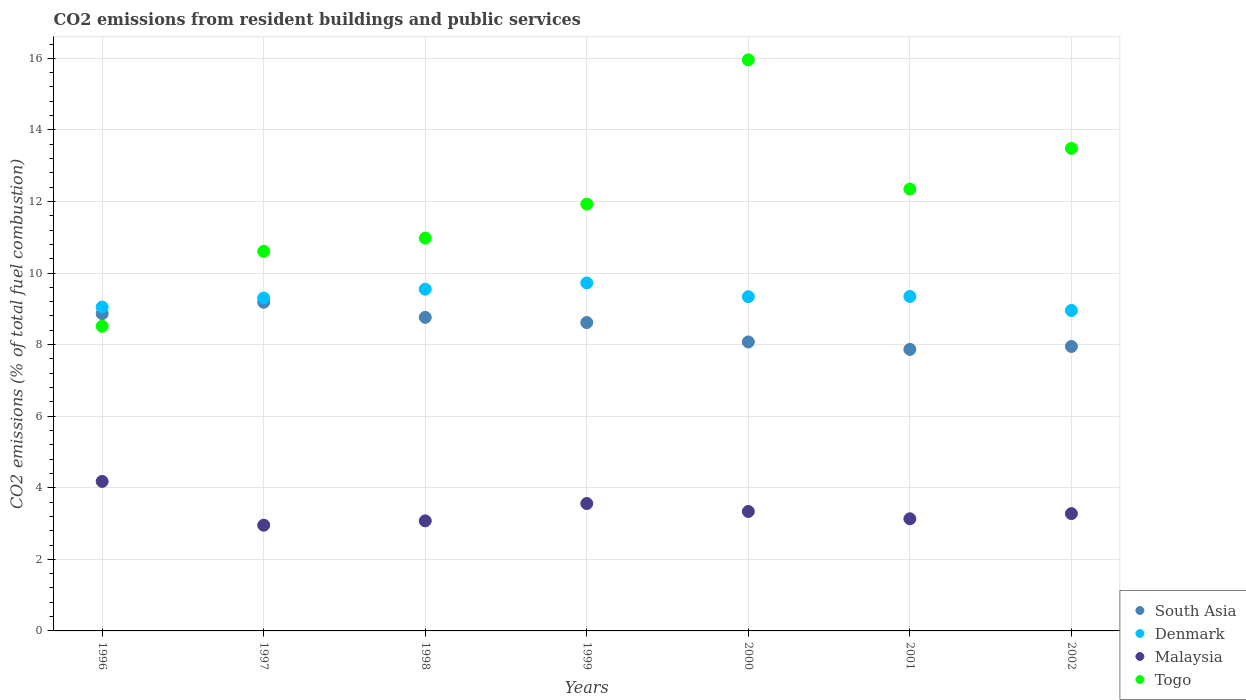How many different coloured dotlines are there?
Make the answer very short. 4. What is the total CO2 emitted in Togo in 1998?
Keep it short and to the point. 10.98. Across all years, what is the maximum total CO2 emitted in Malaysia?
Keep it short and to the point. 4.18. Across all years, what is the minimum total CO2 emitted in Malaysia?
Make the answer very short. 2.95. What is the total total CO2 emitted in South Asia in the graph?
Provide a short and direct response. 59.32. What is the difference between the total CO2 emitted in Malaysia in 1998 and that in 2000?
Your answer should be compact. -0.26. What is the difference between the total CO2 emitted in South Asia in 1999 and the total CO2 emitted in Denmark in 2001?
Provide a short and direct response. -0.73. What is the average total CO2 emitted in Malaysia per year?
Your response must be concise. 3.36. In the year 1998, what is the difference between the total CO2 emitted in Denmark and total CO2 emitted in South Asia?
Your answer should be very brief. 0.79. What is the ratio of the total CO2 emitted in Denmark in 1998 to that in 2001?
Your answer should be compact. 1.02. What is the difference between the highest and the second highest total CO2 emitted in Malaysia?
Your answer should be compact. 0.62. What is the difference between the highest and the lowest total CO2 emitted in Togo?
Your answer should be very brief. 7.45. In how many years, is the total CO2 emitted in Malaysia greater than the average total CO2 emitted in Malaysia taken over all years?
Offer a very short reply. 2. Is the sum of the total CO2 emitted in Togo in 2000 and 2001 greater than the maximum total CO2 emitted in Malaysia across all years?
Give a very brief answer. Yes. Is it the case that in every year, the sum of the total CO2 emitted in Denmark and total CO2 emitted in Togo  is greater than the total CO2 emitted in South Asia?
Ensure brevity in your answer.  Yes. Is the total CO2 emitted in Denmark strictly greater than the total CO2 emitted in Malaysia over the years?
Give a very brief answer. Yes. Is the total CO2 emitted in Denmark strictly less than the total CO2 emitted in Togo over the years?
Provide a short and direct response. No. Are the values on the major ticks of Y-axis written in scientific E-notation?
Offer a terse response. No. Does the graph contain grids?
Provide a short and direct response. Yes. How are the legend labels stacked?
Your response must be concise. Vertical. What is the title of the graph?
Your answer should be compact. CO2 emissions from resident buildings and public services. Does "Fragile and conflict affected situations" appear as one of the legend labels in the graph?
Ensure brevity in your answer.  No. What is the label or title of the Y-axis?
Your response must be concise. CO2 emissions (% of total fuel combustion). What is the CO2 emissions (% of total fuel combustion) in South Asia in 1996?
Offer a very short reply. 8.86. What is the CO2 emissions (% of total fuel combustion) in Denmark in 1996?
Your response must be concise. 9.05. What is the CO2 emissions (% of total fuel combustion) in Malaysia in 1996?
Provide a succinct answer. 4.18. What is the CO2 emissions (% of total fuel combustion) of Togo in 1996?
Make the answer very short. 8.51. What is the CO2 emissions (% of total fuel combustion) of South Asia in 1997?
Offer a very short reply. 9.18. What is the CO2 emissions (% of total fuel combustion) of Denmark in 1997?
Your answer should be compact. 9.3. What is the CO2 emissions (% of total fuel combustion) in Malaysia in 1997?
Your answer should be very brief. 2.95. What is the CO2 emissions (% of total fuel combustion) in Togo in 1997?
Ensure brevity in your answer.  10.61. What is the CO2 emissions (% of total fuel combustion) of South Asia in 1998?
Keep it short and to the point. 8.76. What is the CO2 emissions (% of total fuel combustion) of Denmark in 1998?
Offer a terse response. 9.55. What is the CO2 emissions (% of total fuel combustion) in Malaysia in 1998?
Offer a very short reply. 3.08. What is the CO2 emissions (% of total fuel combustion) in Togo in 1998?
Your answer should be very brief. 10.98. What is the CO2 emissions (% of total fuel combustion) in South Asia in 1999?
Provide a succinct answer. 8.62. What is the CO2 emissions (% of total fuel combustion) in Denmark in 1999?
Your answer should be very brief. 9.72. What is the CO2 emissions (% of total fuel combustion) of Malaysia in 1999?
Your answer should be compact. 3.56. What is the CO2 emissions (% of total fuel combustion) of Togo in 1999?
Provide a short and direct response. 11.93. What is the CO2 emissions (% of total fuel combustion) in South Asia in 2000?
Ensure brevity in your answer.  8.08. What is the CO2 emissions (% of total fuel combustion) of Denmark in 2000?
Your response must be concise. 9.34. What is the CO2 emissions (% of total fuel combustion) in Malaysia in 2000?
Provide a succinct answer. 3.34. What is the CO2 emissions (% of total fuel combustion) of Togo in 2000?
Your answer should be very brief. 15.96. What is the CO2 emissions (% of total fuel combustion) of South Asia in 2001?
Your response must be concise. 7.87. What is the CO2 emissions (% of total fuel combustion) of Denmark in 2001?
Provide a succinct answer. 9.34. What is the CO2 emissions (% of total fuel combustion) of Malaysia in 2001?
Your answer should be very brief. 3.13. What is the CO2 emissions (% of total fuel combustion) in Togo in 2001?
Ensure brevity in your answer.  12.35. What is the CO2 emissions (% of total fuel combustion) of South Asia in 2002?
Your response must be concise. 7.95. What is the CO2 emissions (% of total fuel combustion) in Denmark in 2002?
Offer a very short reply. 8.95. What is the CO2 emissions (% of total fuel combustion) in Malaysia in 2002?
Offer a terse response. 3.28. What is the CO2 emissions (% of total fuel combustion) of Togo in 2002?
Your answer should be compact. 13.48. Across all years, what is the maximum CO2 emissions (% of total fuel combustion) of South Asia?
Give a very brief answer. 9.18. Across all years, what is the maximum CO2 emissions (% of total fuel combustion) of Denmark?
Provide a succinct answer. 9.72. Across all years, what is the maximum CO2 emissions (% of total fuel combustion) in Malaysia?
Make the answer very short. 4.18. Across all years, what is the maximum CO2 emissions (% of total fuel combustion) of Togo?
Your answer should be very brief. 15.96. Across all years, what is the minimum CO2 emissions (% of total fuel combustion) in South Asia?
Provide a succinct answer. 7.87. Across all years, what is the minimum CO2 emissions (% of total fuel combustion) of Denmark?
Offer a terse response. 8.95. Across all years, what is the minimum CO2 emissions (% of total fuel combustion) of Malaysia?
Offer a very short reply. 2.95. Across all years, what is the minimum CO2 emissions (% of total fuel combustion) in Togo?
Your answer should be very brief. 8.51. What is the total CO2 emissions (% of total fuel combustion) in South Asia in the graph?
Your response must be concise. 59.32. What is the total CO2 emissions (% of total fuel combustion) in Denmark in the graph?
Provide a short and direct response. 65.26. What is the total CO2 emissions (% of total fuel combustion) of Malaysia in the graph?
Give a very brief answer. 23.52. What is the total CO2 emissions (% of total fuel combustion) of Togo in the graph?
Offer a terse response. 83.81. What is the difference between the CO2 emissions (% of total fuel combustion) of South Asia in 1996 and that in 1997?
Your answer should be very brief. -0.32. What is the difference between the CO2 emissions (% of total fuel combustion) in Denmark in 1996 and that in 1997?
Keep it short and to the point. -0.25. What is the difference between the CO2 emissions (% of total fuel combustion) in Malaysia in 1996 and that in 1997?
Offer a terse response. 1.22. What is the difference between the CO2 emissions (% of total fuel combustion) in Togo in 1996 and that in 1997?
Keep it short and to the point. -2.1. What is the difference between the CO2 emissions (% of total fuel combustion) of South Asia in 1996 and that in 1998?
Offer a terse response. 0.1. What is the difference between the CO2 emissions (% of total fuel combustion) in Denmark in 1996 and that in 1998?
Make the answer very short. -0.5. What is the difference between the CO2 emissions (% of total fuel combustion) in Malaysia in 1996 and that in 1998?
Make the answer very short. 1.1. What is the difference between the CO2 emissions (% of total fuel combustion) in Togo in 1996 and that in 1998?
Your response must be concise. -2.46. What is the difference between the CO2 emissions (% of total fuel combustion) of South Asia in 1996 and that in 1999?
Provide a succinct answer. 0.25. What is the difference between the CO2 emissions (% of total fuel combustion) in Denmark in 1996 and that in 1999?
Provide a short and direct response. -0.68. What is the difference between the CO2 emissions (% of total fuel combustion) of Malaysia in 1996 and that in 1999?
Keep it short and to the point. 0.62. What is the difference between the CO2 emissions (% of total fuel combustion) in Togo in 1996 and that in 1999?
Keep it short and to the point. -3.42. What is the difference between the CO2 emissions (% of total fuel combustion) in South Asia in 1996 and that in 2000?
Offer a terse response. 0.79. What is the difference between the CO2 emissions (% of total fuel combustion) in Denmark in 1996 and that in 2000?
Ensure brevity in your answer.  -0.29. What is the difference between the CO2 emissions (% of total fuel combustion) in Malaysia in 1996 and that in 2000?
Give a very brief answer. 0.84. What is the difference between the CO2 emissions (% of total fuel combustion) of Togo in 1996 and that in 2000?
Offer a terse response. -7.45. What is the difference between the CO2 emissions (% of total fuel combustion) in South Asia in 1996 and that in 2001?
Give a very brief answer. 1. What is the difference between the CO2 emissions (% of total fuel combustion) in Denmark in 1996 and that in 2001?
Offer a terse response. -0.3. What is the difference between the CO2 emissions (% of total fuel combustion) in Malaysia in 1996 and that in 2001?
Provide a short and direct response. 1.04. What is the difference between the CO2 emissions (% of total fuel combustion) of Togo in 1996 and that in 2001?
Offer a terse response. -3.83. What is the difference between the CO2 emissions (% of total fuel combustion) of South Asia in 1996 and that in 2002?
Provide a succinct answer. 0.92. What is the difference between the CO2 emissions (% of total fuel combustion) of Denmark in 1996 and that in 2002?
Keep it short and to the point. 0.09. What is the difference between the CO2 emissions (% of total fuel combustion) in Malaysia in 1996 and that in 2002?
Keep it short and to the point. 0.9. What is the difference between the CO2 emissions (% of total fuel combustion) in Togo in 1996 and that in 2002?
Offer a very short reply. -4.97. What is the difference between the CO2 emissions (% of total fuel combustion) of South Asia in 1997 and that in 1998?
Your answer should be very brief. 0.42. What is the difference between the CO2 emissions (% of total fuel combustion) in Denmark in 1997 and that in 1998?
Ensure brevity in your answer.  -0.25. What is the difference between the CO2 emissions (% of total fuel combustion) in Malaysia in 1997 and that in 1998?
Provide a short and direct response. -0.12. What is the difference between the CO2 emissions (% of total fuel combustion) of Togo in 1997 and that in 1998?
Ensure brevity in your answer.  -0.37. What is the difference between the CO2 emissions (% of total fuel combustion) of South Asia in 1997 and that in 1999?
Your response must be concise. 0.57. What is the difference between the CO2 emissions (% of total fuel combustion) in Denmark in 1997 and that in 1999?
Keep it short and to the point. -0.42. What is the difference between the CO2 emissions (% of total fuel combustion) of Malaysia in 1997 and that in 1999?
Keep it short and to the point. -0.61. What is the difference between the CO2 emissions (% of total fuel combustion) in Togo in 1997 and that in 1999?
Offer a very short reply. -1.32. What is the difference between the CO2 emissions (% of total fuel combustion) in South Asia in 1997 and that in 2000?
Ensure brevity in your answer.  1.11. What is the difference between the CO2 emissions (% of total fuel combustion) of Denmark in 1997 and that in 2000?
Your answer should be very brief. -0.04. What is the difference between the CO2 emissions (% of total fuel combustion) of Malaysia in 1997 and that in 2000?
Ensure brevity in your answer.  -0.38. What is the difference between the CO2 emissions (% of total fuel combustion) of Togo in 1997 and that in 2000?
Make the answer very short. -5.35. What is the difference between the CO2 emissions (% of total fuel combustion) in South Asia in 1997 and that in 2001?
Provide a short and direct response. 1.32. What is the difference between the CO2 emissions (% of total fuel combustion) in Denmark in 1997 and that in 2001?
Your response must be concise. -0.04. What is the difference between the CO2 emissions (% of total fuel combustion) in Malaysia in 1997 and that in 2001?
Offer a very short reply. -0.18. What is the difference between the CO2 emissions (% of total fuel combustion) in Togo in 1997 and that in 2001?
Your answer should be compact. -1.74. What is the difference between the CO2 emissions (% of total fuel combustion) of South Asia in 1997 and that in 2002?
Provide a short and direct response. 1.24. What is the difference between the CO2 emissions (% of total fuel combustion) in Denmark in 1997 and that in 2002?
Make the answer very short. 0.35. What is the difference between the CO2 emissions (% of total fuel combustion) of Malaysia in 1997 and that in 2002?
Provide a short and direct response. -0.32. What is the difference between the CO2 emissions (% of total fuel combustion) in Togo in 1997 and that in 2002?
Give a very brief answer. -2.88. What is the difference between the CO2 emissions (% of total fuel combustion) in South Asia in 1998 and that in 1999?
Give a very brief answer. 0.15. What is the difference between the CO2 emissions (% of total fuel combustion) in Denmark in 1998 and that in 1999?
Your response must be concise. -0.18. What is the difference between the CO2 emissions (% of total fuel combustion) in Malaysia in 1998 and that in 1999?
Ensure brevity in your answer.  -0.48. What is the difference between the CO2 emissions (% of total fuel combustion) in Togo in 1998 and that in 1999?
Offer a terse response. -0.95. What is the difference between the CO2 emissions (% of total fuel combustion) of South Asia in 1998 and that in 2000?
Ensure brevity in your answer.  0.69. What is the difference between the CO2 emissions (% of total fuel combustion) of Denmark in 1998 and that in 2000?
Your response must be concise. 0.21. What is the difference between the CO2 emissions (% of total fuel combustion) in Malaysia in 1998 and that in 2000?
Your answer should be very brief. -0.26. What is the difference between the CO2 emissions (% of total fuel combustion) in Togo in 1998 and that in 2000?
Ensure brevity in your answer.  -4.98. What is the difference between the CO2 emissions (% of total fuel combustion) of South Asia in 1998 and that in 2001?
Offer a very short reply. 0.9. What is the difference between the CO2 emissions (% of total fuel combustion) of Denmark in 1998 and that in 2001?
Keep it short and to the point. 0.2. What is the difference between the CO2 emissions (% of total fuel combustion) of Malaysia in 1998 and that in 2001?
Your response must be concise. -0.06. What is the difference between the CO2 emissions (% of total fuel combustion) in Togo in 1998 and that in 2001?
Provide a short and direct response. -1.37. What is the difference between the CO2 emissions (% of total fuel combustion) in South Asia in 1998 and that in 2002?
Make the answer very short. 0.81. What is the difference between the CO2 emissions (% of total fuel combustion) of Denmark in 1998 and that in 2002?
Provide a succinct answer. 0.59. What is the difference between the CO2 emissions (% of total fuel combustion) of Malaysia in 1998 and that in 2002?
Provide a short and direct response. -0.2. What is the difference between the CO2 emissions (% of total fuel combustion) in Togo in 1998 and that in 2002?
Ensure brevity in your answer.  -2.51. What is the difference between the CO2 emissions (% of total fuel combustion) of South Asia in 1999 and that in 2000?
Your response must be concise. 0.54. What is the difference between the CO2 emissions (% of total fuel combustion) in Denmark in 1999 and that in 2000?
Ensure brevity in your answer.  0.39. What is the difference between the CO2 emissions (% of total fuel combustion) in Malaysia in 1999 and that in 2000?
Your response must be concise. 0.22. What is the difference between the CO2 emissions (% of total fuel combustion) in Togo in 1999 and that in 2000?
Offer a very short reply. -4.03. What is the difference between the CO2 emissions (% of total fuel combustion) in South Asia in 1999 and that in 2001?
Offer a very short reply. 0.75. What is the difference between the CO2 emissions (% of total fuel combustion) in Denmark in 1999 and that in 2001?
Your response must be concise. 0.38. What is the difference between the CO2 emissions (% of total fuel combustion) in Malaysia in 1999 and that in 2001?
Your answer should be compact. 0.43. What is the difference between the CO2 emissions (% of total fuel combustion) in Togo in 1999 and that in 2001?
Make the answer very short. -0.42. What is the difference between the CO2 emissions (% of total fuel combustion) of South Asia in 1999 and that in 2002?
Your response must be concise. 0.67. What is the difference between the CO2 emissions (% of total fuel combustion) in Denmark in 1999 and that in 2002?
Ensure brevity in your answer.  0.77. What is the difference between the CO2 emissions (% of total fuel combustion) in Malaysia in 1999 and that in 2002?
Offer a very short reply. 0.28. What is the difference between the CO2 emissions (% of total fuel combustion) of Togo in 1999 and that in 2002?
Give a very brief answer. -1.56. What is the difference between the CO2 emissions (% of total fuel combustion) in South Asia in 2000 and that in 2001?
Give a very brief answer. 0.21. What is the difference between the CO2 emissions (% of total fuel combustion) of Denmark in 2000 and that in 2001?
Give a very brief answer. -0.01. What is the difference between the CO2 emissions (% of total fuel combustion) of Malaysia in 2000 and that in 2001?
Make the answer very short. 0.2. What is the difference between the CO2 emissions (% of total fuel combustion) of Togo in 2000 and that in 2001?
Ensure brevity in your answer.  3.61. What is the difference between the CO2 emissions (% of total fuel combustion) in South Asia in 2000 and that in 2002?
Provide a succinct answer. 0.13. What is the difference between the CO2 emissions (% of total fuel combustion) of Denmark in 2000 and that in 2002?
Your answer should be compact. 0.38. What is the difference between the CO2 emissions (% of total fuel combustion) of Malaysia in 2000 and that in 2002?
Make the answer very short. 0.06. What is the difference between the CO2 emissions (% of total fuel combustion) in Togo in 2000 and that in 2002?
Your answer should be very brief. 2.47. What is the difference between the CO2 emissions (% of total fuel combustion) of South Asia in 2001 and that in 2002?
Offer a terse response. -0.08. What is the difference between the CO2 emissions (% of total fuel combustion) of Denmark in 2001 and that in 2002?
Provide a short and direct response. 0.39. What is the difference between the CO2 emissions (% of total fuel combustion) of Malaysia in 2001 and that in 2002?
Provide a succinct answer. -0.14. What is the difference between the CO2 emissions (% of total fuel combustion) in Togo in 2001 and that in 2002?
Provide a succinct answer. -1.14. What is the difference between the CO2 emissions (% of total fuel combustion) of South Asia in 1996 and the CO2 emissions (% of total fuel combustion) of Denmark in 1997?
Keep it short and to the point. -0.44. What is the difference between the CO2 emissions (% of total fuel combustion) in South Asia in 1996 and the CO2 emissions (% of total fuel combustion) in Malaysia in 1997?
Give a very brief answer. 5.91. What is the difference between the CO2 emissions (% of total fuel combustion) in South Asia in 1996 and the CO2 emissions (% of total fuel combustion) in Togo in 1997?
Provide a succinct answer. -1.74. What is the difference between the CO2 emissions (% of total fuel combustion) of Denmark in 1996 and the CO2 emissions (% of total fuel combustion) of Malaysia in 1997?
Offer a terse response. 6.09. What is the difference between the CO2 emissions (% of total fuel combustion) of Denmark in 1996 and the CO2 emissions (% of total fuel combustion) of Togo in 1997?
Give a very brief answer. -1.56. What is the difference between the CO2 emissions (% of total fuel combustion) of Malaysia in 1996 and the CO2 emissions (% of total fuel combustion) of Togo in 1997?
Your answer should be very brief. -6.43. What is the difference between the CO2 emissions (% of total fuel combustion) in South Asia in 1996 and the CO2 emissions (% of total fuel combustion) in Denmark in 1998?
Your response must be concise. -0.68. What is the difference between the CO2 emissions (% of total fuel combustion) of South Asia in 1996 and the CO2 emissions (% of total fuel combustion) of Malaysia in 1998?
Your answer should be compact. 5.79. What is the difference between the CO2 emissions (% of total fuel combustion) in South Asia in 1996 and the CO2 emissions (% of total fuel combustion) in Togo in 1998?
Provide a short and direct response. -2.11. What is the difference between the CO2 emissions (% of total fuel combustion) of Denmark in 1996 and the CO2 emissions (% of total fuel combustion) of Malaysia in 1998?
Ensure brevity in your answer.  5.97. What is the difference between the CO2 emissions (% of total fuel combustion) of Denmark in 1996 and the CO2 emissions (% of total fuel combustion) of Togo in 1998?
Ensure brevity in your answer.  -1.93. What is the difference between the CO2 emissions (% of total fuel combustion) of Malaysia in 1996 and the CO2 emissions (% of total fuel combustion) of Togo in 1998?
Ensure brevity in your answer.  -6.8. What is the difference between the CO2 emissions (% of total fuel combustion) in South Asia in 1996 and the CO2 emissions (% of total fuel combustion) in Denmark in 1999?
Provide a short and direct response. -0.86. What is the difference between the CO2 emissions (% of total fuel combustion) of South Asia in 1996 and the CO2 emissions (% of total fuel combustion) of Malaysia in 1999?
Keep it short and to the point. 5.3. What is the difference between the CO2 emissions (% of total fuel combustion) of South Asia in 1996 and the CO2 emissions (% of total fuel combustion) of Togo in 1999?
Your answer should be compact. -3.06. What is the difference between the CO2 emissions (% of total fuel combustion) in Denmark in 1996 and the CO2 emissions (% of total fuel combustion) in Malaysia in 1999?
Your response must be concise. 5.49. What is the difference between the CO2 emissions (% of total fuel combustion) in Denmark in 1996 and the CO2 emissions (% of total fuel combustion) in Togo in 1999?
Your answer should be compact. -2.88. What is the difference between the CO2 emissions (% of total fuel combustion) of Malaysia in 1996 and the CO2 emissions (% of total fuel combustion) of Togo in 1999?
Offer a terse response. -7.75. What is the difference between the CO2 emissions (% of total fuel combustion) in South Asia in 1996 and the CO2 emissions (% of total fuel combustion) in Denmark in 2000?
Offer a very short reply. -0.47. What is the difference between the CO2 emissions (% of total fuel combustion) of South Asia in 1996 and the CO2 emissions (% of total fuel combustion) of Malaysia in 2000?
Offer a terse response. 5.53. What is the difference between the CO2 emissions (% of total fuel combustion) of South Asia in 1996 and the CO2 emissions (% of total fuel combustion) of Togo in 2000?
Provide a succinct answer. -7.09. What is the difference between the CO2 emissions (% of total fuel combustion) in Denmark in 1996 and the CO2 emissions (% of total fuel combustion) in Malaysia in 2000?
Offer a very short reply. 5.71. What is the difference between the CO2 emissions (% of total fuel combustion) in Denmark in 1996 and the CO2 emissions (% of total fuel combustion) in Togo in 2000?
Ensure brevity in your answer.  -6.91. What is the difference between the CO2 emissions (% of total fuel combustion) of Malaysia in 1996 and the CO2 emissions (% of total fuel combustion) of Togo in 2000?
Give a very brief answer. -11.78. What is the difference between the CO2 emissions (% of total fuel combustion) in South Asia in 1996 and the CO2 emissions (% of total fuel combustion) in Denmark in 2001?
Offer a terse response. -0.48. What is the difference between the CO2 emissions (% of total fuel combustion) of South Asia in 1996 and the CO2 emissions (% of total fuel combustion) of Malaysia in 2001?
Provide a succinct answer. 5.73. What is the difference between the CO2 emissions (% of total fuel combustion) in South Asia in 1996 and the CO2 emissions (% of total fuel combustion) in Togo in 2001?
Ensure brevity in your answer.  -3.48. What is the difference between the CO2 emissions (% of total fuel combustion) of Denmark in 1996 and the CO2 emissions (% of total fuel combustion) of Malaysia in 2001?
Offer a very short reply. 5.92. What is the difference between the CO2 emissions (% of total fuel combustion) of Denmark in 1996 and the CO2 emissions (% of total fuel combustion) of Togo in 2001?
Give a very brief answer. -3.3. What is the difference between the CO2 emissions (% of total fuel combustion) of Malaysia in 1996 and the CO2 emissions (% of total fuel combustion) of Togo in 2001?
Make the answer very short. -8.17. What is the difference between the CO2 emissions (% of total fuel combustion) in South Asia in 1996 and the CO2 emissions (% of total fuel combustion) in Denmark in 2002?
Your answer should be compact. -0.09. What is the difference between the CO2 emissions (% of total fuel combustion) of South Asia in 1996 and the CO2 emissions (% of total fuel combustion) of Malaysia in 2002?
Your answer should be very brief. 5.59. What is the difference between the CO2 emissions (% of total fuel combustion) in South Asia in 1996 and the CO2 emissions (% of total fuel combustion) in Togo in 2002?
Your response must be concise. -4.62. What is the difference between the CO2 emissions (% of total fuel combustion) in Denmark in 1996 and the CO2 emissions (% of total fuel combustion) in Malaysia in 2002?
Offer a terse response. 5.77. What is the difference between the CO2 emissions (% of total fuel combustion) of Denmark in 1996 and the CO2 emissions (% of total fuel combustion) of Togo in 2002?
Make the answer very short. -4.43. What is the difference between the CO2 emissions (% of total fuel combustion) of Malaysia in 1996 and the CO2 emissions (% of total fuel combustion) of Togo in 2002?
Your response must be concise. -9.31. What is the difference between the CO2 emissions (% of total fuel combustion) in South Asia in 1997 and the CO2 emissions (% of total fuel combustion) in Denmark in 1998?
Offer a terse response. -0.36. What is the difference between the CO2 emissions (% of total fuel combustion) of South Asia in 1997 and the CO2 emissions (% of total fuel combustion) of Malaysia in 1998?
Keep it short and to the point. 6.11. What is the difference between the CO2 emissions (% of total fuel combustion) in South Asia in 1997 and the CO2 emissions (% of total fuel combustion) in Togo in 1998?
Your answer should be compact. -1.79. What is the difference between the CO2 emissions (% of total fuel combustion) of Denmark in 1997 and the CO2 emissions (% of total fuel combustion) of Malaysia in 1998?
Your response must be concise. 6.23. What is the difference between the CO2 emissions (% of total fuel combustion) in Denmark in 1997 and the CO2 emissions (% of total fuel combustion) in Togo in 1998?
Keep it short and to the point. -1.67. What is the difference between the CO2 emissions (% of total fuel combustion) in Malaysia in 1997 and the CO2 emissions (% of total fuel combustion) in Togo in 1998?
Your answer should be very brief. -8.02. What is the difference between the CO2 emissions (% of total fuel combustion) in South Asia in 1997 and the CO2 emissions (% of total fuel combustion) in Denmark in 1999?
Provide a short and direct response. -0.54. What is the difference between the CO2 emissions (% of total fuel combustion) of South Asia in 1997 and the CO2 emissions (% of total fuel combustion) of Malaysia in 1999?
Keep it short and to the point. 5.62. What is the difference between the CO2 emissions (% of total fuel combustion) of South Asia in 1997 and the CO2 emissions (% of total fuel combustion) of Togo in 1999?
Keep it short and to the point. -2.74. What is the difference between the CO2 emissions (% of total fuel combustion) in Denmark in 1997 and the CO2 emissions (% of total fuel combustion) in Malaysia in 1999?
Give a very brief answer. 5.74. What is the difference between the CO2 emissions (% of total fuel combustion) of Denmark in 1997 and the CO2 emissions (% of total fuel combustion) of Togo in 1999?
Your answer should be compact. -2.62. What is the difference between the CO2 emissions (% of total fuel combustion) of Malaysia in 1997 and the CO2 emissions (% of total fuel combustion) of Togo in 1999?
Offer a terse response. -8.97. What is the difference between the CO2 emissions (% of total fuel combustion) of South Asia in 1997 and the CO2 emissions (% of total fuel combustion) of Denmark in 2000?
Offer a terse response. -0.15. What is the difference between the CO2 emissions (% of total fuel combustion) in South Asia in 1997 and the CO2 emissions (% of total fuel combustion) in Malaysia in 2000?
Keep it short and to the point. 5.85. What is the difference between the CO2 emissions (% of total fuel combustion) of South Asia in 1997 and the CO2 emissions (% of total fuel combustion) of Togo in 2000?
Your response must be concise. -6.77. What is the difference between the CO2 emissions (% of total fuel combustion) of Denmark in 1997 and the CO2 emissions (% of total fuel combustion) of Malaysia in 2000?
Give a very brief answer. 5.97. What is the difference between the CO2 emissions (% of total fuel combustion) in Denmark in 1997 and the CO2 emissions (% of total fuel combustion) in Togo in 2000?
Your answer should be compact. -6.65. What is the difference between the CO2 emissions (% of total fuel combustion) of Malaysia in 1997 and the CO2 emissions (% of total fuel combustion) of Togo in 2000?
Provide a short and direct response. -13. What is the difference between the CO2 emissions (% of total fuel combustion) of South Asia in 1997 and the CO2 emissions (% of total fuel combustion) of Denmark in 2001?
Your answer should be compact. -0.16. What is the difference between the CO2 emissions (% of total fuel combustion) of South Asia in 1997 and the CO2 emissions (% of total fuel combustion) of Malaysia in 2001?
Give a very brief answer. 6.05. What is the difference between the CO2 emissions (% of total fuel combustion) in South Asia in 1997 and the CO2 emissions (% of total fuel combustion) in Togo in 2001?
Make the answer very short. -3.16. What is the difference between the CO2 emissions (% of total fuel combustion) of Denmark in 1997 and the CO2 emissions (% of total fuel combustion) of Malaysia in 2001?
Your response must be concise. 6.17. What is the difference between the CO2 emissions (% of total fuel combustion) in Denmark in 1997 and the CO2 emissions (% of total fuel combustion) in Togo in 2001?
Your response must be concise. -3.04. What is the difference between the CO2 emissions (% of total fuel combustion) in Malaysia in 1997 and the CO2 emissions (% of total fuel combustion) in Togo in 2001?
Give a very brief answer. -9.39. What is the difference between the CO2 emissions (% of total fuel combustion) in South Asia in 1997 and the CO2 emissions (% of total fuel combustion) in Denmark in 2002?
Make the answer very short. 0.23. What is the difference between the CO2 emissions (% of total fuel combustion) of South Asia in 1997 and the CO2 emissions (% of total fuel combustion) of Malaysia in 2002?
Ensure brevity in your answer.  5.91. What is the difference between the CO2 emissions (% of total fuel combustion) in South Asia in 1997 and the CO2 emissions (% of total fuel combustion) in Togo in 2002?
Provide a succinct answer. -4.3. What is the difference between the CO2 emissions (% of total fuel combustion) of Denmark in 1997 and the CO2 emissions (% of total fuel combustion) of Malaysia in 2002?
Ensure brevity in your answer.  6.02. What is the difference between the CO2 emissions (% of total fuel combustion) of Denmark in 1997 and the CO2 emissions (% of total fuel combustion) of Togo in 2002?
Give a very brief answer. -4.18. What is the difference between the CO2 emissions (% of total fuel combustion) in Malaysia in 1997 and the CO2 emissions (% of total fuel combustion) in Togo in 2002?
Your answer should be very brief. -10.53. What is the difference between the CO2 emissions (% of total fuel combustion) in South Asia in 1998 and the CO2 emissions (% of total fuel combustion) in Denmark in 1999?
Your response must be concise. -0.96. What is the difference between the CO2 emissions (% of total fuel combustion) in South Asia in 1998 and the CO2 emissions (% of total fuel combustion) in Malaysia in 1999?
Provide a succinct answer. 5.2. What is the difference between the CO2 emissions (% of total fuel combustion) of South Asia in 1998 and the CO2 emissions (% of total fuel combustion) of Togo in 1999?
Keep it short and to the point. -3.16. What is the difference between the CO2 emissions (% of total fuel combustion) of Denmark in 1998 and the CO2 emissions (% of total fuel combustion) of Malaysia in 1999?
Ensure brevity in your answer.  5.99. What is the difference between the CO2 emissions (% of total fuel combustion) in Denmark in 1998 and the CO2 emissions (% of total fuel combustion) in Togo in 1999?
Your response must be concise. -2.38. What is the difference between the CO2 emissions (% of total fuel combustion) in Malaysia in 1998 and the CO2 emissions (% of total fuel combustion) in Togo in 1999?
Make the answer very short. -8.85. What is the difference between the CO2 emissions (% of total fuel combustion) in South Asia in 1998 and the CO2 emissions (% of total fuel combustion) in Denmark in 2000?
Keep it short and to the point. -0.58. What is the difference between the CO2 emissions (% of total fuel combustion) of South Asia in 1998 and the CO2 emissions (% of total fuel combustion) of Malaysia in 2000?
Your response must be concise. 5.42. What is the difference between the CO2 emissions (% of total fuel combustion) of South Asia in 1998 and the CO2 emissions (% of total fuel combustion) of Togo in 2000?
Offer a terse response. -7.2. What is the difference between the CO2 emissions (% of total fuel combustion) in Denmark in 1998 and the CO2 emissions (% of total fuel combustion) in Malaysia in 2000?
Make the answer very short. 6.21. What is the difference between the CO2 emissions (% of total fuel combustion) in Denmark in 1998 and the CO2 emissions (% of total fuel combustion) in Togo in 2000?
Your answer should be very brief. -6.41. What is the difference between the CO2 emissions (% of total fuel combustion) of Malaysia in 1998 and the CO2 emissions (% of total fuel combustion) of Togo in 2000?
Your answer should be compact. -12.88. What is the difference between the CO2 emissions (% of total fuel combustion) of South Asia in 1998 and the CO2 emissions (% of total fuel combustion) of Denmark in 2001?
Keep it short and to the point. -0.58. What is the difference between the CO2 emissions (% of total fuel combustion) of South Asia in 1998 and the CO2 emissions (% of total fuel combustion) of Malaysia in 2001?
Ensure brevity in your answer.  5.63. What is the difference between the CO2 emissions (% of total fuel combustion) of South Asia in 1998 and the CO2 emissions (% of total fuel combustion) of Togo in 2001?
Provide a succinct answer. -3.58. What is the difference between the CO2 emissions (% of total fuel combustion) in Denmark in 1998 and the CO2 emissions (% of total fuel combustion) in Malaysia in 2001?
Make the answer very short. 6.41. What is the difference between the CO2 emissions (% of total fuel combustion) of Denmark in 1998 and the CO2 emissions (% of total fuel combustion) of Togo in 2001?
Keep it short and to the point. -2.8. What is the difference between the CO2 emissions (% of total fuel combustion) in Malaysia in 1998 and the CO2 emissions (% of total fuel combustion) in Togo in 2001?
Your answer should be compact. -9.27. What is the difference between the CO2 emissions (% of total fuel combustion) in South Asia in 1998 and the CO2 emissions (% of total fuel combustion) in Denmark in 2002?
Offer a very short reply. -0.19. What is the difference between the CO2 emissions (% of total fuel combustion) of South Asia in 1998 and the CO2 emissions (% of total fuel combustion) of Malaysia in 2002?
Keep it short and to the point. 5.48. What is the difference between the CO2 emissions (% of total fuel combustion) of South Asia in 1998 and the CO2 emissions (% of total fuel combustion) of Togo in 2002?
Keep it short and to the point. -4.72. What is the difference between the CO2 emissions (% of total fuel combustion) of Denmark in 1998 and the CO2 emissions (% of total fuel combustion) of Malaysia in 2002?
Provide a short and direct response. 6.27. What is the difference between the CO2 emissions (% of total fuel combustion) in Denmark in 1998 and the CO2 emissions (% of total fuel combustion) in Togo in 2002?
Your answer should be very brief. -3.93. What is the difference between the CO2 emissions (% of total fuel combustion) of Malaysia in 1998 and the CO2 emissions (% of total fuel combustion) of Togo in 2002?
Your answer should be compact. -10.41. What is the difference between the CO2 emissions (% of total fuel combustion) in South Asia in 1999 and the CO2 emissions (% of total fuel combustion) in Denmark in 2000?
Give a very brief answer. -0.72. What is the difference between the CO2 emissions (% of total fuel combustion) in South Asia in 1999 and the CO2 emissions (% of total fuel combustion) in Malaysia in 2000?
Keep it short and to the point. 5.28. What is the difference between the CO2 emissions (% of total fuel combustion) of South Asia in 1999 and the CO2 emissions (% of total fuel combustion) of Togo in 2000?
Your response must be concise. -7.34. What is the difference between the CO2 emissions (% of total fuel combustion) in Denmark in 1999 and the CO2 emissions (% of total fuel combustion) in Malaysia in 2000?
Keep it short and to the point. 6.39. What is the difference between the CO2 emissions (% of total fuel combustion) in Denmark in 1999 and the CO2 emissions (% of total fuel combustion) in Togo in 2000?
Your answer should be very brief. -6.23. What is the difference between the CO2 emissions (% of total fuel combustion) of Malaysia in 1999 and the CO2 emissions (% of total fuel combustion) of Togo in 2000?
Your response must be concise. -12.4. What is the difference between the CO2 emissions (% of total fuel combustion) of South Asia in 1999 and the CO2 emissions (% of total fuel combustion) of Denmark in 2001?
Offer a terse response. -0.73. What is the difference between the CO2 emissions (% of total fuel combustion) in South Asia in 1999 and the CO2 emissions (% of total fuel combustion) in Malaysia in 2001?
Your answer should be compact. 5.48. What is the difference between the CO2 emissions (% of total fuel combustion) in South Asia in 1999 and the CO2 emissions (% of total fuel combustion) in Togo in 2001?
Provide a succinct answer. -3.73. What is the difference between the CO2 emissions (% of total fuel combustion) of Denmark in 1999 and the CO2 emissions (% of total fuel combustion) of Malaysia in 2001?
Ensure brevity in your answer.  6.59. What is the difference between the CO2 emissions (% of total fuel combustion) in Denmark in 1999 and the CO2 emissions (% of total fuel combustion) in Togo in 2001?
Offer a terse response. -2.62. What is the difference between the CO2 emissions (% of total fuel combustion) in Malaysia in 1999 and the CO2 emissions (% of total fuel combustion) in Togo in 2001?
Provide a short and direct response. -8.79. What is the difference between the CO2 emissions (% of total fuel combustion) of South Asia in 1999 and the CO2 emissions (% of total fuel combustion) of Denmark in 2002?
Offer a very short reply. -0.34. What is the difference between the CO2 emissions (% of total fuel combustion) of South Asia in 1999 and the CO2 emissions (% of total fuel combustion) of Malaysia in 2002?
Ensure brevity in your answer.  5.34. What is the difference between the CO2 emissions (% of total fuel combustion) in South Asia in 1999 and the CO2 emissions (% of total fuel combustion) in Togo in 2002?
Offer a very short reply. -4.87. What is the difference between the CO2 emissions (% of total fuel combustion) in Denmark in 1999 and the CO2 emissions (% of total fuel combustion) in Malaysia in 2002?
Give a very brief answer. 6.45. What is the difference between the CO2 emissions (% of total fuel combustion) of Denmark in 1999 and the CO2 emissions (% of total fuel combustion) of Togo in 2002?
Make the answer very short. -3.76. What is the difference between the CO2 emissions (% of total fuel combustion) of Malaysia in 1999 and the CO2 emissions (% of total fuel combustion) of Togo in 2002?
Your answer should be very brief. -9.92. What is the difference between the CO2 emissions (% of total fuel combustion) of South Asia in 2000 and the CO2 emissions (% of total fuel combustion) of Denmark in 2001?
Your response must be concise. -1.27. What is the difference between the CO2 emissions (% of total fuel combustion) in South Asia in 2000 and the CO2 emissions (% of total fuel combustion) in Malaysia in 2001?
Provide a short and direct response. 4.94. What is the difference between the CO2 emissions (% of total fuel combustion) of South Asia in 2000 and the CO2 emissions (% of total fuel combustion) of Togo in 2001?
Provide a succinct answer. -4.27. What is the difference between the CO2 emissions (% of total fuel combustion) in Denmark in 2000 and the CO2 emissions (% of total fuel combustion) in Malaysia in 2001?
Your response must be concise. 6.2. What is the difference between the CO2 emissions (% of total fuel combustion) in Denmark in 2000 and the CO2 emissions (% of total fuel combustion) in Togo in 2001?
Provide a succinct answer. -3.01. What is the difference between the CO2 emissions (% of total fuel combustion) in Malaysia in 2000 and the CO2 emissions (% of total fuel combustion) in Togo in 2001?
Make the answer very short. -9.01. What is the difference between the CO2 emissions (% of total fuel combustion) in South Asia in 2000 and the CO2 emissions (% of total fuel combustion) in Denmark in 2002?
Offer a very short reply. -0.88. What is the difference between the CO2 emissions (% of total fuel combustion) in South Asia in 2000 and the CO2 emissions (% of total fuel combustion) in Malaysia in 2002?
Offer a very short reply. 4.8. What is the difference between the CO2 emissions (% of total fuel combustion) of South Asia in 2000 and the CO2 emissions (% of total fuel combustion) of Togo in 2002?
Make the answer very short. -5.41. What is the difference between the CO2 emissions (% of total fuel combustion) of Denmark in 2000 and the CO2 emissions (% of total fuel combustion) of Malaysia in 2002?
Give a very brief answer. 6.06. What is the difference between the CO2 emissions (% of total fuel combustion) in Denmark in 2000 and the CO2 emissions (% of total fuel combustion) in Togo in 2002?
Give a very brief answer. -4.15. What is the difference between the CO2 emissions (% of total fuel combustion) of Malaysia in 2000 and the CO2 emissions (% of total fuel combustion) of Togo in 2002?
Your answer should be very brief. -10.15. What is the difference between the CO2 emissions (% of total fuel combustion) of South Asia in 2001 and the CO2 emissions (% of total fuel combustion) of Denmark in 2002?
Keep it short and to the point. -1.09. What is the difference between the CO2 emissions (% of total fuel combustion) of South Asia in 2001 and the CO2 emissions (% of total fuel combustion) of Malaysia in 2002?
Keep it short and to the point. 4.59. What is the difference between the CO2 emissions (% of total fuel combustion) in South Asia in 2001 and the CO2 emissions (% of total fuel combustion) in Togo in 2002?
Keep it short and to the point. -5.62. What is the difference between the CO2 emissions (% of total fuel combustion) of Denmark in 2001 and the CO2 emissions (% of total fuel combustion) of Malaysia in 2002?
Offer a terse response. 6.07. What is the difference between the CO2 emissions (% of total fuel combustion) of Denmark in 2001 and the CO2 emissions (% of total fuel combustion) of Togo in 2002?
Ensure brevity in your answer.  -4.14. What is the difference between the CO2 emissions (% of total fuel combustion) in Malaysia in 2001 and the CO2 emissions (% of total fuel combustion) in Togo in 2002?
Offer a very short reply. -10.35. What is the average CO2 emissions (% of total fuel combustion) of South Asia per year?
Make the answer very short. 8.47. What is the average CO2 emissions (% of total fuel combustion) in Denmark per year?
Provide a short and direct response. 9.32. What is the average CO2 emissions (% of total fuel combustion) of Malaysia per year?
Give a very brief answer. 3.36. What is the average CO2 emissions (% of total fuel combustion) in Togo per year?
Give a very brief answer. 11.97. In the year 1996, what is the difference between the CO2 emissions (% of total fuel combustion) in South Asia and CO2 emissions (% of total fuel combustion) in Denmark?
Your answer should be compact. -0.18. In the year 1996, what is the difference between the CO2 emissions (% of total fuel combustion) in South Asia and CO2 emissions (% of total fuel combustion) in Malaysia?
Provide a short and direct response. 4.69. In the year 1996, what is the difference between the CO2 emissions (% of total fuel combustion) in South Asia and CO2 emissions (% of total fuel combustion) in Togo?
Provide a short and direct response. 0.35. In the year 1996, what is the difference between the CO2 emissions (% of total fuel combustion) in Denmark and CO2 emissions (% of total fuel combustion) in Malaysia?
Provide a succinct answer. 4.87. In the year 1996, what is the difference between the CO2 emissions (% of total fuel combustion) of Denmark and CO2 emissions (% of total fuel combustion) of Togo?
Give a very brief answer. 0.54. In the year 1996, what is the difference between the CO2 emissions (% of total fuel combustion) of Malaysia and CO2 emissions (% of total fuel combustion) of Togo?
Provide a short and direct response. -4.33. In the year 1997, what is the difference between the CO2 emissions (% of total fuel combustion) in South Asia and CO2 emissions (% of total fuel combustion) in Denmark?
Give a very brief answer. -0.12. In the year 1997, what is the difference between the CO2 emissions (% of total fuel combustion) in South Asia and CO2 emissions (% of total fuel combustion) in Malaysia?
Your answer should be very brief. 6.23. In the year 1997, what is the difference between the CO2 emissions (% of total fuel combustion) in South Asia and CO2 emissions (% of total fuel combustion) in Togo?
Your response must be concise. -1.42. In the year 1997, what is the difference between the CO2 emissions (% of total fuel combustion) in Denmark and CO2 emissions (% of total fuel combustion) in Malaysia?
Offer a very short reply. 6.35. In the year 1997, what is the difference between the CO2 emissions (% of total fuel combustion) of Denmark and CO2 emissions (% of total fuel combustion) of Togo?
Your answer should be compact. -1.3. In the year 1997, what is the difference between the CO2 emissions (% of total fuel combustion) of Malaysia and CO2 emissions (% of total fuel combustion) of Togo?
Your answer should be very brief. -7.65. In the year 1998, what is the difference between the CO2 emissions (% of total fuel combustion) in South Asia and CO2 emissions (% of total fuel combustion) in Denmark?
Provide a short and direct response. -0.79. In the year 1998, what is the difference between the CO2 emissions (% of total fuel combustion) of South Asia and CO2 emissions (% of total fuel combustion) of Malaysia?
Keep it short and to the point. 5.69. In the year 1998, what is the difference between the CO2 emissions (% of total fuel combustion) of South Asia and CO2 emissions (% of total fuel combustion) of Togo?
Make the answer very short. -2.21. In the year 1998, what is the difference between the CO2 emissions (% of total fuel combustion) in Denmark and CO2 emissions (% of total fuel combustion) in Malaysia?
Your answer should be very brief. 6.47. In the year 1998, what is the difference between the CO2 emissions (% of total fuel combustion) in Denmark and CO2 emissions (% of total fuel combustion) in Togo?
Provide a short and direct response. -1.43. In the year 1998, what is the difference between the CO2 emissions (% of total fuel combustion) of Malaysia and CO2 emissions (% of total fuel combustion) of Togo?
Offer a very short reply. -7.9. In the year 1999, what is the difference between the CO2 emissions (% of total fuel combustion) of South Asia and CO2 emissions (% of total fuel combustion) of Denmark?
Make the answer very short. -1.11. In the year 1999, what is the difference between the CO2 emissions (% of total fuel combustion) in South Asia and CO2 emissions (% of total fuel combustion) in Malaysia?
Ensure brevity in your answer.  5.06. In the year 1999, what is the difference between the CO2 emissions (% of total fuel combustion) of South Asia and CO2 emissions (% of total fuel combustion) of Togo?
Make the answer very short. -3.31. In the year 1999, what is the difference between the CO2 emissions (% of total fuel combustion) in Denmark and CO2 emissions (% of total fuel combustion) in Malaysia?
Your response must be concise. 6.16. In the year 1999, what is the difference between the CO2 emissions (% of total fuel combustion) in Denmark and CO2 emissions (% of total fuel combustion) in Togo?
Offer a terse response. -2.2. In the year 1999, what is the difference between the CO2 emissions (% of total fuel combustion) in Malaysia and CO2 emissions (% of total fuel combustion) in Togo?
Give a very brief answer. -8.37. In the year 2000, what is the difference between the CO2 emissions (% of total fuel combustion) in South Asia and CO2 emissions (% of total fuel combustion) in Denmark?
Offer a terse response. -1.26. In the year 2000, what is the difference between the CO2 emissions (% of total fuel combustion) of South Asia and CO2 emissions (% of total fuel combustion) of Malaysia?
Ensure brevity in your answer.  4.74. In the year 2000, what is the difference between the CO2 emissions (% of total fuel combustion) in South Asia and CO2 emissions (% of total fuel combustion) in Togo?
Provide a succinct answer. -7.88. In the year 2000, what is the difference between the CO2 emissions (% of total fuel combustion) in Denmark and CO2 emissions (% of total fuel combustion) in Malaysia?
Give a very brief answer. 6. In the year 2000, what is the difference between the CO2 emissions (% of total fuel combustion) of Denmark and CO2 emissions (% of total fuel combustion) of Togo?
Your response must be concise. -6.62. In the year 2000, what is the difference between the CO2 emissions (% of total fuel combustion) of Malaysia and CO2 emissions (% of total fuel combustion) of Togo?
Give a very brief answer. -12.62. In the year 2001, what is the difference between the CO2 emissions (% of total fuel combustion) of South Asia and CO2 emissions (% of total fuel combustion) of Denmark?
Your response must be concise. -1.48. In the year 2001, what is the difference between the CO2 emissions (% of total fuel combustion) of South Asia and CO2 emissions (% of total fuel combustion) of Malaysia?
Your answer should be very brief. 4.73. In the year 2001, what is the difference between the CO2 emissions (% of total fuel combustion) in South Asia and CO2 emissions (% of total fuel combustion) in Togo?
Keep it short and to the point. -4.48. In the year 2001, what is the difference between the CO2 emissions (% of total fuel combustion) of Denmark and CO2 emissions (% of total fuel combustion) of Malaysia?
Offer a very short reply. 6.21. In the year 2001, what is the difference between the CO2 emissions (% of total fuel combustion) in Denmark and CO2 emissions (% of total fuel combustion) in Togo?
Offer a very short reply. -3. In the year 2001, what is the difference between the CO2 emissions (% of total fuel combustion) of Malaysia and CO2 emissions (% of total fuel combustion) of Togo?
Your answer should be very brief. -9.21. In the year 2002, what is the difference between the CO2 emissions (% of total fuel combustion) of South Asia and CO2 emissions (% of total fuel combustion) of Denmark?
Keep it short and to the point. -1.01. In the year 2002, what is the difference between the CO2 emissions (% of total fuel combustion) of South Asia and CO2 emissions (% of total fuel combustion) of Malaysia?
Offer a terse response. 4.67. In the year 2002, what is the difference between the CO2 emissions (% of total fuel combustion) in South Asia and CO2 emissions (% of total fuel combustion) in Togo?
Your answer should be very brief. -5.53. In the year 2002, what is the difference between the CO2 emissions (% of total fuel combustion) in Denmark and CO2 emissions (% of total fuel combustion) in Malaysia?
Provide a short and direct response. 5.68. In the year 2002, what is the difference between the CO2 emissions (% of total fuel combustion) in Denmark and CO2 emissions (% of total fuel combustion) in Togo?
Keep it short and to the point. -4.53. In the year 2002, what is the difference between the CO2 emissions (% of total fuel combustion) of Malaysia and CO2 emissions (% of total fuel combustion) of Togo?
Give a very brief answer. -10.21. What is the ratio of the CO2 emissions (% of total fuel combustion) of South Asia in 1996 to that in 1997?
Give a very brief answer. 0.97. What is the ratio of the CO2 emissions (% of total fuel combustion) in Denmark in 1996 to that in 1997?
Keep it short and to the point. 0.97. What is the ratio of the CO2 emissions (% of total fuel combustion) in Malaysia in 1996 to that in 1997?
Your response must be concise. 1.41. What is the ratio of the CO2 emissions (% of total fuel combustion) in Togo in 1996 to that in 1997?
Make the answer very short. 0.8. What is the ratio of the CO2 emissions (% of total fuel combustion) in South Asia in 1996 to that in 1998?
Offer a very short reply. 1.01. What is the ratio of the CO2 emissions (% of total fuel combustion) of Denmark in 1996 to that in 1998?
Offer a terse response. 0.95. What is the ratio of the CO2 emissions (% of total fuel combustion) in Malaysia in 1996 to that in 1998?
Your answer should be compact. 1.36. What is the ratio of the CO2 emissions (% of total fuel combustion) of Togo in 1996 to that in 1998?
Provide a short and direct response. 0.78. What is the ratio of the CO2 emissions (% of total fuel combustion) of South Asia in 1996 to that in 1999?
Your answer should be compact. 1.03. What is the ratio of the CO2 emissions (% of total fuel combustion) in Denmark in 1996 to that in 1999?
Your answer should be compact. 0.93. What is the ratio of the CO2 emissions (% of total fuel combustion) of Malaysia in 1996 to that in 1999?
Offer a very short reply. 1.17. What is the ratio of the CO2 emissions (% of total fuel combustion) of Togo in 1996 to that in 1999?
Give a very brief answer. 0.71. What is the ratio of the CO2 emissions (% of total fuel combustion) in South Asia in 1996 to that in 2000?
Ensure brevity in your answer.  1.1. What is the ratio of the CO2 emissions (% of total fuel combustion) in Malaysia in 1996 to that in 2000?
Your response must be concise. 1.25. What is the ratio of the CO2 emissions (% of total fuel combustion) of Togo in 1996 to that in 2000?
Provide a succinct answer. 0.53. What is the ratio of the CO2 emissions (% of total fuel combustion) of South Asia in 1996 to that in 2001?
Make the answer very short. 1.13. What is the ratio of the CO2 emissions (% of total fuel combustion) in Denmark in 1996 to that in 2001?
Offer a very short reply. 0.97. What is the ratio of the CO2 emissions (% of total fuel combustion) in Malaysia in 1996 to that in 2001?
Make the answer very short. 1.33. What is the ratio of the CO2 emissions (% of total fuel combustion) in Togo in 1996 to that in 2001?
Provide a succinct answer. 0.69. What is the ratio of the CO2 emissions (% of total fuel combustion) of South Asia in 1996 to that in 2002?
Your answer should be compact. 1.12. What is the ratio of the CO2 emissions (% of total fuel combustion) in Denmark in 1996 to that in 2002?
Keep it short and to the point. 1.01. What is the ratio of the CO2 emissions (% of total fuel combustion) in Malaysia in 1996 to that in 2002?
Provide a short and direct response. 1.27. What is the ratio of the CO2 emissions (% of total fuel combustion) in Togo in 1996 to that in 2002?
Ensure brevity in your answer.  0.63. What is the ratio of the CO2 emissions (% of total fuel combustion) in South Asia in 1997 to that in 1998?
Ensure brevity in your answer.  1.05. What is the ratio of the CO2 emissions (% of total fuel combustion) in Denmark in 1997 to that in 1998?
Keep it short and to the point. 0.97. What is the ratio of the CO2 emissions (% of total fuel combustion) in Malaysia in 1997 to that in 1998?
Your response must be concise. 0.96. What is the ratio of the CO2 emissions (% of total fuel combustion) in Togo in 1997 to that in 1998?
Offer a terse response. 0.97. What is the ratio of the CO2 emissions (% of total fuel combustion) in South Asia in 1997 to that in 1999?
Your response must be concise. 1.07. What is the ratio of the CO2 emissions (% of total fuel combustion) in Denmark in 1997 to that in 1999?
Your answer should be very brief. 0.96. What is the ratio of the CO2 emissions (% of total fuel combustion) in Malaysia in 1997 to that in 1999?
Ensure brevity in your answer.  0.83. What is the ratio of the CO2 emissions (% of total fuel combustion) of Togo in 1997 to that in 1999?
Provide a short and direct response. 0.89. What is the ratio of the CO2 emissions (% of total fuel combustion) of South Asia in 1997 to that in 2000?
Your response must be concise. 1.14. What is the ratio of the CO2 emissions (% of total fuel combustion) of Malaysia in 1997 to that in 2000?
Your answer should be compact. 0.89. What is the ratio of the CO2 emissions (% of total fuel combustion) in Togo in 1997 to that in 2000?
Make the answer very short. 0.66. What is the ratio of the CO2 emissions (% of total fuel combustion) of South Asia in 1997 to that in 2001?
Keep it short and to the point. 1.17. What is the ratio of the CO2 emissions (% of total fuel combustion) of Malaysia in 1997 to that in 2001?
Ensure brevity in your answer.  0.94. What is the ratio of the CO2 emissions (% of total fuel combustion) of Togo in 1997 to that in 2001?
Make the answer very short. 0.86. What is the ratio of the CO2 emissions (% of total fuel combustion) in South Asia in 1997 to that in 2002?
Keep it short and to the point. 1.16. What is the ratio of the CO2 emissions (% of total fuel combustion) of Denmark in 1997 to that in 2002?
Make the answer very short. 1.04. What is the ratio of the CO2 emissions (% of total fuel combustion) in Malaysia in 1997 to that in 2002?
Offer a very short reply. 0.9. What is the ratio of the CO2 emissions (% of total fuel combustion) of Togo in 1997 to that in 2002?
Keep it short and to the point. 0.79. What is the ratio of the CO2 emissions (% of total fuel combustion) in South Asia in 1998 to that in 1999?
Ensure brevity in your answer.  1.02. What is the ratio of the CO2 emissions (% of total fuel combustion) in Denmark in 1998 to that in 1999?
Provide a succinct answer. 0.98. What is the ratio of the CO2 emissions (% of total fuel combustion) of Malaysia in 1998 to that in 1999?
Your answer should be very brief. 0.86. What is the ratio of the CO2 emissions (% of total fuel combustion) in Togo in 1998 to that in 1999?
Offer a terse response. 0.92. What is the ratio of the CO2 emissions (% of total fuel combustion) in South Asia in 1998 to that in 2000?
Provide a short and direct response. 1.08. What is the ratio of the CO2 emissions (% of total fuel combustion) in Denmark in 1998 to that in 2000?
Provide a short and direct response. 1.02. What is the ratio of the CO2 emissions (% of total fuel combustion) in Malaysia in 1998 to that in 2000?
Offer a terse response. 0.92. What is the ratio of the CO2 emissions (% of total fuel combustion) of Togo in 1998 to that in 2000?
Offer a terse response. 0.69. What is the ratio of the CO2 emissions (% of total fuel combustion) of South Asia in 1998 to that in 2001?
Provide a short and direct response. 1.11. What is the ratio of the CO2 emissions (% of total fuel combustion) in Denmark in 1998 to that in 2001?
Keep it short and to the point. 1.02. What is the ratio of the CO2 emissions (% of total fuel combustion) in Malaysia in 1998 to that in 2001?
Your response must be concise. 0.98. What is the ratio of the CO2 emissions (% of total fuel combustion) in Togo in 1998 to that in 2001?
Provide a succinct answer. 0.89. What is the ratio of the CO2 emissions (% of total fuel combustion) in South Asia in 1998 to that in 2002?
Provide a succinct answer. 1.1. What is the ratio of the CO2 emissions (% of total fuel combustion) in Denmark in 1998 to that in 2002?
Make the answer very short. 1.07. What is the ratio of the CO2 emissions (% of total fuel combustion) of Malaysia in 1998 to that in 2002?
Your answer should be very brief. 0.94. What is the ratio of the CO2 emissions (% of total fuel combustion) in Togo in 1998 to that in 2002?
Your answer should be very brief. 0.81. What is the ratio of the CO2 emissions (% of total fuel combustion) of South Asia in 1999 to that in 2000?
Your response must be concise. 1.07. What is the ratio of the CO2 emissions (% of total fuel combustion) in Denmark in 1999 to that in 2000?
Offer a very short reply. 1.04. What is the ratio of the CO2 emissions (% of total fuel combustion) of Malaysia in 1999 to that in 2000?
Offer a very short reply. 1.07. What is the ratio of the CO2 emissions (% of total fuel combustion) of Togo in 1999 to that in 2000?
Offer a terse response. 0.75. What is the ratio of the CO2 emissions (% of total fuel combustion) in South Asia in 1999 to that in 2001?
Ensure brevity in your answer.  1.1. What is the ratio of the CO2 emissions (% of total fuel combustion) in Denmark in 1999 to that in 2001?
Provide a short and direct response. 1.04. What is the ratio of the CO2 emissions (% of total fuel combustion) in Malaysia in 1999 to that in 2001?
Your answer should be very brief. 1.14. What is the ratio of the CO2 emissions (% of total fuel combustion) in Togo in 1999 to that in 2001?
Keep it short and to the point. 0.97. What is the ratio of the CO2 emissions (% of total fuel combustion) in South Asia in 1999 to that in 2002?
Keep it short and to the point. 1.08. What is the ratio of the CO2 emissions (% of total fuel combustion) in Denmark in 1999 to that in 2002?
Make the answer very short. 1.09. What is the ratio of the CO2 emissions (% of total fuel combustion) of Malaysia in 1999 to that in 2002?
Ensure brevity in your answer.  1.09. What is the ratio of the CO2 emissions (% of total fuel combustion) of Togo in 1999 to that in 2002?
Your response must be concise. 0.88. What is the ratio of the CO2 emissions (% of total fuel combustion) in South Asia in 2000 to that in 2001?
Your answer should be very brief. 1.03. What is the ratio of the CO2 emissions (% of total fuel combustion) of Denmark in 2000 to that in 2001?
Offer a terse response. 1. What is the ratio of the CO2 emissions (% of total fuel combustion) of Malaysia in 2000 to that in 2001?
Your answer should be compact. 1.07. What is the ratio of the CO2 emissions (% of total fuel combustion) in Togo in 2000 to that in 2001?
Ensure brevity in your answer.  1.29. What is the ratio of the CO2 emissions (% of total fuel combustion) in South Asia in 2000 to that in 2002?
Make the answer very short. 1.02. What is the ratio of the CO2 emissions (% of total fuel combustion) in Denmark in 2000 to that in 2002?
Offer a terse response. 1.04. What is the ratio of the CO2 emissions (% of total fuel combustion) in Malaysia in 2000 to that in 2002?
Offer a terse response. 1.02. What is the ratio of the CO2 emissions (% of total fuel combustion) of Togo in 2000 to that in 2002?
Your response must be concise. 1.18. What is the ratio of the CO2 emissions (% of total fuel combustion) in South Asia in 2001 to that in 2002?
Give a very brief answer. 0.99. What is the ratio of the CO2 emissions (% of total fuel combustion) of Denmark in 2001 to that in 2002?
Provide a short and direct response. 1.04. What is the ratio of the CO2 emissions (% of total fuel combustion) of Malaysia in 2001 to that in 2002?
Ensure brevity in your answer.  0.96. What is the ratio of the CO2 emissions (% of total fuel combustion) in Togo in 2001 to that in 2002?
Offer a terse response. 0.92. What is the difference between the highest and the second highest CO2 emissions (% of total fuel combustion) of South Asia?
Provide a short and direct response. 0.32. What is the difference between the highest and the second highest CO2 emissions (% of total fuel combustion) in Denmark?
Give a very brief answer. 0.18. What is the difference between the highest and the second highest CO2 emissions (% of total fuel combustion) in Malaysia?
Offer a very short reply. 0.62. What is the difference between the highest and the second highest CO2 emissions (% of total fuel combustion) in Togo?
Offer a very short reply. 2.47. What is the difference between the highest and the lowest CO2 emissions (% of total fuel combustion) of South Asia?
Offer a terse response. 1.32. What is the difference between the highest and the lowest CO2 emissions (% of total fuel combustion) in Denmark?
Make the answer very short. 0.77. What is the difference between the highest and the lowest CO2 emissions (% of total fuel combustion) in Malaysia?
Give a very brief answer. 1.22. What is the difference between the highest and the lowest CO2 emissions (% of total fuel combustion) in Togo?
Make the answer very short. 7.45. 